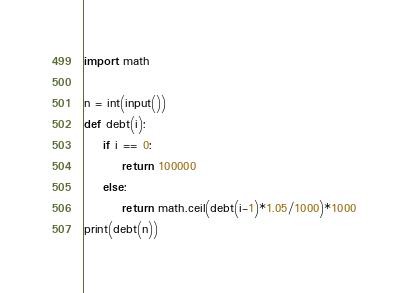<code> <loc_0><loc_0><loc_500><loc_500><_Python_>import math

n = int(input())
def debt(i):
    if i == 0:
        return 100000
    else:
        return math.ceil(debt(i-1)*1.05/1000)*1000
print(debt(n))
</code> 